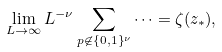<formula> <loc_0><loc_0><loc_500><loc_500>\lim _ { L \to \infty } L ^ { - \nu } \sum _ { p \not \in \{ 0 , 1 \} ^ { \nu } } \dots = \zeta ( z _ { * } ) ,</formula> 